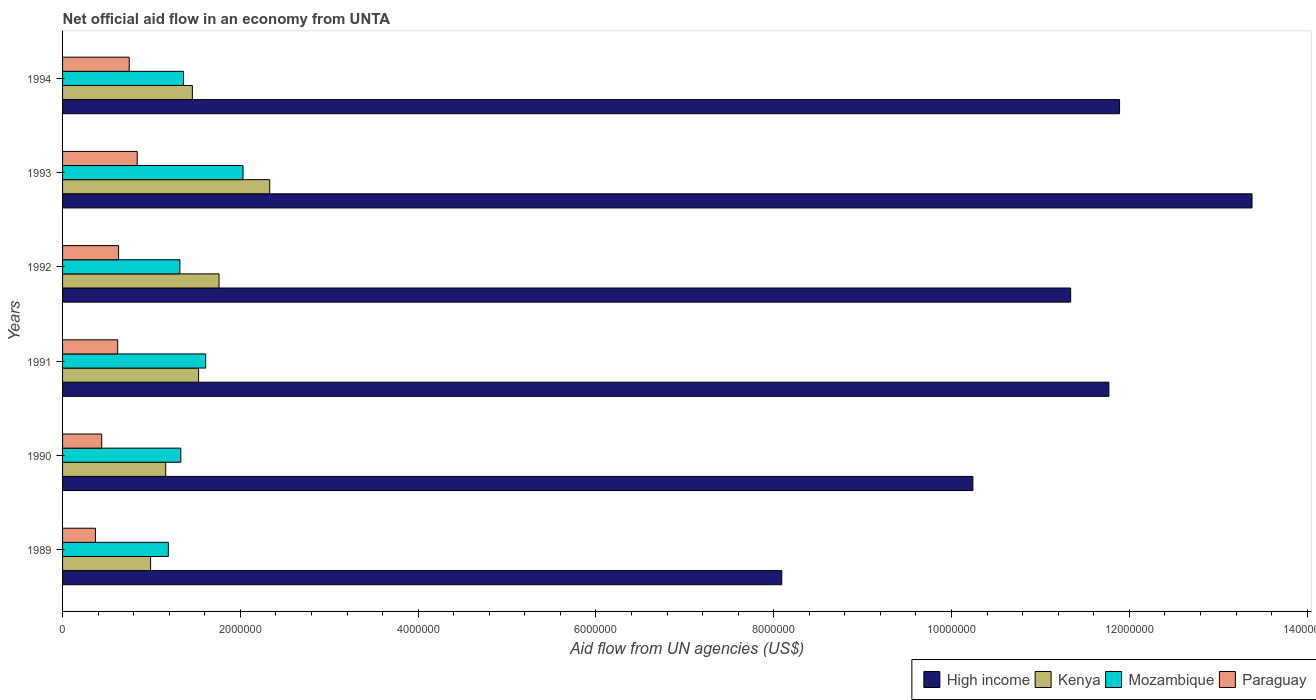How many different coloured bars are there?
Your answer should be compact. 4. Are the number of bars per tick equal to the number of legend labels?
Provide a short and direct response. Yes. In how many cases, is the number of bars for a given year not equal to the number of legend labels?
Ensure brevity in your answer.  0. What is the net official aid flow in Paraguay in 1994?
Give a very brief answer. 7.50e+05. Across all years, what is the maximum net official aid flow in Paraguay?
Give a very brief answer. 8.40e+05. Across all years, what is the minimum net official aid flow in Paraguay?
Offer a terse response. 3.70e+05. What is the total net official aid flow in High income in the graph?
Ensure brevity in your answer.  6.67e+07. What is the difference between the net official aid flow in High income in 1991 and that in 1993?
Provide a short and direct response. -1.61e+06. What is the difference between the net official aid flow in Kenya in 1994 and the net official aid flow in High income in 1993?
Make the answer very short. -1.19e+07. What is the average net official aid flow in Mozambique per year?
Offer a terse response. 1.47e+06. In the year 1992, what is the difference between the net official aid flow in High income and net official aid flow in Paraguay?
Your answer should be compact. 1.07e+07. What is the ratio of the net official aid flow in High income in 1991 to that in 1992?
Provide a succinct answer. 1.04. Is the net official aid flow in Mozambique in 1989 less than that in 1993?
Offer a very short reply. Yes. Is the difference between the net official aid flow in High income in 1989 and 1993 greater than the difference between the net official aid flow in Paraguay in 1989 and 1993?
Make the answer very short. No. What is the difference between the highest and the second highest net official aid flow in High income?
Make the answer very short. 1.49e+06. What is the difference between the highest and the lowest net official aid flow in High income?
Give a very brief answer. 5.29e+06. In how many years, is the net official aid flow in Mozambique greater than the average net official aid flow in Mozambique taken over all years?
Make the answer very short. 2. What does the 3rd bar from the top in 1993 represents?
Make the answer very short. Kenya. What does the 4th bar from the bottom in 1994 represents?
Give a very brief answer. Paraguay. Is it the case that in every year, the sum of the net official aid flow in Kenya and net official aid flow in Paraguay is greater than the net official aid flow in High income?
Provide a succinct answer. No. Are all the bars in the graph horizontal?
Keep it short and to the point. Yes. How many years are there in the graph?
Make the answer very short. 6. What is the difference between two consecutive major ticks on the X-axis?
Give a very brief answer. 2.00e+06. Does the graph contain any zero values?
Offer a terse response. No. Does the graph contain grids?
Make the answer very short. No. What is the title of the graph?
Give a very brief answer. Net official aid flow in an economy from UNTA. What is the label or title of the X-axis?
Make the answer very short. Aid flow from UN agencies (US$). What is the label or title of the Y-axis?
Keep it short and to the point. Years. What is the Aid flow from UN agencies (US$) of High income in 1989?
Ensure brevity in your answer.  8.09e+06. What is the Aid flow from UN agencies (US$) of Kenya in 1989?
Offer a terse response. 9.90e+05. What is the Aid flow from UN agencies (US$) in Mozambique in 1989?
Give a very brief answer. 1.19e+06. What is the Aid flow from UN agencies (US$) in High income in 1990?
Provide a short and direct response. 1.02e+07. What is the Aid flow from UN agencies (US$) of Kenya in 1990?
Offer a terse response. 1.16e+06. What is the Aid flow from UN agencies (US$) in Mozambique in 1990?
Give a very brief answer. 1.33e+06. What is the Aid flow from UN agencies (US$) in High income in 1991?
Provide a short and direct response. 1.18e+07. What is the Aid flow from UN agencies (US$) in Kenya in 1991?
Your answer should be compact. 1.53e+06. What is the Aid flow from UN agencies (US$) of Mozambique in 1991?
Your answer should be very brief. 1.61e+06. What is the Aid flow from UN agencies (US$) of Paraguay in 1991?
Your answer should be very brief. 6.20e+05. What is the Aid flow from UN agencies (US$) in High income in 1992?
Provide a short and direct response. 1.13e+07. What is the Aid flow from UN agencies (US$) in Kenya in 1992?
Provide a short and direct response. 1.76e+06. What is the Aid flow from UN agencies (US$) in Mozambique in 1992?
Your response must be concise. 1.32e+06. What is the Aid flow from UN agencies (US$) in Paraguay in 1992?
Provide a short and direct response. 6.30e+05. What is the Aid flow from UN agencies (US$) of High income in 1993?
Make the answer very short. 1.34e+07. What is the Aid flow from UN agencies (US$) in Kenya in 1993?
Offer a very short reply. 2.33e+06. What is the Aid flow from UN agencies (US$) of Mozambique in 1993?
Ensure brevity in your answer.  2.03e+06. What is the Aid flow from UN agencies (US$) in Paraguay in 1993?
Give a very brief answer. 8.40e+05. What is the Aid flow from UN agencies (US$) in High income in 1994?
Ensure brevity in your answer.  1.19e+07. What is the Aid flow from UN agencies (US$) of Kenya in 1994?
Offer a very short reply. 1.46e+06. What is the Aid flow from UN agencies (US$) of Mozambique in 1994?
Offer a very short reply. 1.36e+06. What is the Aid flow from UN agencies (US$) of Paraguay in 1994?
Offer a terse response. 7.50e+05. Across all years, what is the maximum Aid flow from UN agencies (US$) in High income?
Provide a short and direct response. 1.34e+07. Across all years, what is the maximum Aid flow from UN agencies (US$) in Kenya?
Offer a very short reply. 2.33e+06. Across all years, what is the maximum Aid flow from UN agencies (US$) in Mozambique?
Your response must be concise. 2.03e+06. Across all years, what is the maximum Aid flow from UN agencies (US$) in Paraguay?
Provide a succinct answer. 8.40e+05. Across all years, what is the minimum Aid flow from UN agencies (US$) in High income?
Provide a succinct answer. 8.09e+06. Across all years, what is the minimum Aid flow from UN agencies (US$) in Kenya?
Your answer should be very brief. 9.90e+05. Across all years, what is the minimum Aid flow from UN agencies (US$) of Mozambique?
Your answer should be very brief. 1.19e+06. Across all years, what is the minimum Aid flow from UN agencies (US$) in Paraguay?
Provide a short and direct response. 3.70e+05. What is the total Aid flow from UN agencies (US$) of High income in the graph?
Offer a terse response. 6.67e+07. What is the total Aid flow from UN agencies (US$) of Kenya in the graph?
Make the answer very short. 9.23e+06. What is the total Aid flow from UN agencies (US$) of Mozambique in the graph?
Offer a very short reply. 8.84e+06. What is the total Aid flow from UN agencies (US$) of Paraguay in the graph?
Offer a terse response. 3.65e+06. What is the difference between the Aid flow from UN agencies (US$) in High income in 1989 and that in 1990?
Provide a succinct answer. -2.15e+06. What is the difference between the Aid flow from UN agencies (US$) in High income in 1989 and that in 1991?
Make the answer very short. -3.68e+06. What is the difference between the Aid flow from UN agencies (US$) of Kenya in 1989 and that in 1991?
Your response must be concise. -5.40e+05. What is the difference between the Aid flow from UN agencies (US$) in Mozambique in 1989 and that in 1991?
Your answer should be very brief. -4.20e+05. What is the difference between the Aid flow from UN agencies (US$) of High income in 1989 and that in 1992?
Your response must be concise. -3.25e+06. What is the difference between the Aid flow from UN agencies (US$) of Kenya in 1989 and that in 1992?
Keep it short and to the point. -7.70e+05. What is the difference between the Aid flow from UN agencies (US$) of Mozambique in 1989 and that in 1992?
Make the answer very short. -1.30e+05. What is the difference between the Aid flow from UN agencies (US$) of Paraguay in 1989 and that in 1992?
Provide a short and direct response. -2.60e+05. What is the difference between the Aid flow from UN agencies (US$) of High income in 1989 and that in 1993?
Offer a terse response. -5.29e+06. What is the difference between the Aid flow from UN agencies (US$) in Kenya in 1989 and that in 1993?
Make the answer very short. -1.34e+06. What is the difference between the Aid flow from UN agencies (US$) in Mozambique in 1989 and that in 1993?
Offer a very short reply. -8.40e+05. What is the difference between the Aid flow from UN agencies (US$) in Paraguay in 1989 and that in 1993?
Offer a terse response. -4.70e+05. What is the difference between the Aid flow from UN agencies (US$) in High income in 1989 and that in 1994?
Offer a terse response. -3.80e+06. What is the difference between the Aid flow from UN agencies (US$) of Kenya in 1989 and that in 1994?
Offer a very short reply. -4.70e+05. What is the difference between the Aid flow from UN agencies (US$) in Paraguay in 1989 and that in 1994?
Ensure brevity in your answer.  -3.80e+05. What is the difference between the Aid flow from UN agencies (US$) in High income in 1990 and that in 1991?
Keep it short and to the point. -1.53e+06. What is the difference between the Aid flow from UN agencies (US$) in Kenya in 1990 and that in 1991?
Ensure brevity in your answer.  -3.70e+05. What is the difference between the Aid flow from UN agencies (US$) in Mozambique in 1990 and that in 1991?
Provide a succinct answer. -2.80e+05. What is the difference between the Aid flow from UN agencies (US$) in Paraguay in 1990 and that in 1991?
Offer a very short reply. -1.80e+05. What is the difference between the Aid flow from UN agencies (US$) in High income in 1990 and that in 1992?
Provide a succinct answer. -1.10e+06. What is the difference between the Aid flow from UN agencies (US$) in Kenya in 1990 and that in 1992?
Offer a very short reply. -6.00e+05. What is the difference between the Aid flow from UN agencies (US$) in Mozambique in 1990 and that in 1992?
Your response must be concise. 10000. What is the difference between the Aid flow from UN agencies (US$) in Paraguay in 1990 and that in 1992?
Keep it short and to the point. -1.90e+05. What is the difference between the Aid flow from UN agencies (US$) of High income in 1990 and that in 1993?
Your answer should be very brief. -3.14e+06. What is the difference between the Aid flow from UN agencies (US$) in Kenya in 1990 and that in 1993?
Your answer should be compact. -1.17e+06. What is the difference between the Aid flow from UN agencies (US$) in Mozambique in 1990 and that in 1993?
Provide a succinct answer. -7.00e+05. What is the difference between the Aid flow from UN agencies (US$) of Paraguay in 1990 and that in 1993?
Provide a short and direct response. -4.00e+05. What is the difference between the Aid flow from UN agencies (US$) of High income in 1990 and that in 1994?
Provide a succinct answer. -1.65e+06. What is the difference between the Aid flow from UN agencies (US$) in Mozambique in 1990 and that in 1994?
Keep it short and to the point. -3.00e+04. What is the difference between the Aid flow from UN agencies (US$) in Paraguay in 1990 and that in 1994?
Make the answer very short. -3.10e+05. What is the difference between the Aid flow from UN agencies (US$) of High income in 1991 and that in 1992?
Provide a short and direct response. 4.30e+05. What is the difference between the Aid flow from UN agencies (US$) of Mozambique in 1991 and that in 1992?
Offer a very short reply. 2.90e+05. What is the difference between the Aid flow from UN agencies (US$) in High income in 1991 and that in 1993?
Ensure brevity in your answer.  -1.61e+06. What is the difference between the Aid flow from UN agencies (US$) in Kenya in 1991 and that in 1993?
Ensure brevity in your answer.  -8.00e+05. What is the difference between the Aid flow from UN agencies (US$) of Mozambique in 1991 and that in 1993?
Your answer should be very brief. -4.20e+05. What is the difference between the Aid flow from UN agencies (US$) of Paraguay in 1991 and that in 1994?
Keep it short and to the point. -1.30e+05. What is the difference between the Aid flow from UN agencies (US$) of High income in 1992 and that in 1993?
Ensure brevity in your answer.  -2.04e+06. What is the difference between the Aid flow from UN agencies (US$) in Kenya in 1992 and that in 1993?
Your answer should be very brief. -5.70e+05. What is the difference between the Aid flow from UN agencies (US$) of Mozambique in 1992 and that in 1993?
Offer a terse response. -7.10e+05. What is the difference between the Aid flow from UN agencies (US$) of High income in 1992 and that in 1994?
Give a very brief answer. -5.50e+05. What is the difference between the Aid flow from UN agencies (US$) of Paraguay in 1992 and that in 1994?
Give a very brief answer. -1.20e+05. What is the difference between the Aid flow from UN agencies (US$) in High income in 1993 and that in 1994?
Your answer should be compact. 1.49e+06. What is the difference between the Aid flow from UN agencies (US$) in Kenya in 1993 and that in 1994?
Ensure brevity in your answer.  8.70e+05. What is the difference between the Aid flow from UN agencies (US$) in Mozambique in 1993 and that in 1994?
Ensure brevity in your answer.  6.70e+05. What is the difference between the Aid flow from UN agencies (US$) of Paraguay in 1993 and that in 1994?
Your answer should be compact. 9.00e+04. What is the difference between the Aid flow from UN agencies (US$) of High income in 1989 and the Aid flow from UN agencies (US$) of Kenya in 1990?
Your answer should be compact. 6.93e+06. What is the difference between the Aid flow from UN agencies (US$) in High income in 1989 and the Aid flow from UN agencies (US$) in Mozambique in 1990?
Offer a terse response. 6.76e+06. What is the difference between the Aid flow from UN agencies (US$) in High income in 1989 and the Aid flow from UN agencies (US$) in Paraguay in 1990?
Make the answer very short. 7.65e+06. What is the difference between the Aid flow from UN agencies (US$) of Kenya in 1989 and the Aid flow from UN agencies (US$) of Mozambique in 1990?
Your response must be concise. -3.40e+05. What is the difference between the Aid flow from UN agencies (US$) in Kenya in 1989 and the Aid flow from UN agencies (US$) in Paraguay in 1990?
Keep it short and to the point. 5.50e+05. What is the difference between the Aid flow from UN agencies (US$) of Mozambique in 1989 and the Aid flow from UN agencies (US$) of Paraguay in 1990?
Give a very brief answer. 7.50e+05. What is the difference between the Aid flow from UN agencies (US$) of High income in 1989 and the Aid flow from UN agencies (US$) of Kenya in 1991?
Keep it short and to the point. 6.56e+06. What is the difference between the Aid flow from UN agencies (US$) of High income in 1989 and the Aid flow from UN agencies (US$) of Mozambique in 1991?
Keep it short and to the point. 6.48e+06. What is the difference between the Aid flow from UN agencies (US$) in High income in 1989 and the Aid flow from UN agencies (US$) in Paraguay in 1991?
Give a very brief answer. 7.47e+06. What is the difference between the Aid flow from UN agencies (US$) in Kenya in 1989 and the Aid flow from UN agencies (US$) in Mozambique in 1991?
Your answer should be very brief. -6.20e+05. What is the difference between the Aid flow from UN agencies (US$) in Kenya in 1989 and the Aid flow from UN agencies (US$) in Paraguay in 1991?
Ensure brevity in your answer.  3.70e+05. What is the difference between the Aid flow from UN agencies (US$) of Mozambique in 1989 and the Aid flow from UN agencies (US$) of Paraguay in 1991?
Offer a very short reply. 5.70e+05. What is the difference between the Aid flow from UN agencies (US$) in High income in 1989 and the Aid flow from UN agencies (US$) in Kenya in 1992?
Make the answer very short. 6.33e+06. What is the difference between the Aid flow from UN agencies (US$) in High income in 1989 and the Aid flow from UN agencies (US$) in Mozambique in 1992?
Provide a succinct answer. 6.77e+06. What is the difference between the Aid flow from UN agencies (US$) of High income in 1989 and the Aid flow from UN agencies (US$) of Paraguay in 1992?
Your answer should be compact. 7.46e+06. What is the difference between the Aid flow from UN agencies (US$) of Kenya in 1989 and the Aid flow from UN agencies (US$) of Mozambique in 1992?
Offer a terse response. -3.30e+05. What is the difference between the Aid flow from UN agencies (US$) of Mozambique in 1989 and the Aid flow from UN agencies (US$) of Paraguay in 1992?
Your answer should be compact. 5.60e+05. What is the difference between the Aid flow from UN agencies (US$) in High income in 1989 and the Aid flow from UN agencies (US$) in Kenya in 1993?
Your answer should be very brief. 5.76e+06. What is the difference between the Aid flow from UN agencies (US$) of High income in 1989 and the Aid flow from UN agencies (US$) of Mozambique in 1993?
Your answer should be very brief. 6.06e+06. What is the difference between the Aid flow from UN agencies (US$) in High income in 1989 and the Aid flow from UN agencies (US$) in Paraguay in 1993?
Provide a short and direct response. 7.25e+06. What is the difference between the Aid flow from UN agencies (US$) of Kenya in 1989 and the Aid flow from UN agencies (US$) of Mozambique in 1993?
Provide a succinct answer. -1.04e+06. What is the difference between the Aid flow from UN agencies (US$) of High income in 1989 and the Aid flow from UN agencies (US$) of Kenya in 1994?
Your answer should be very brief. 6.63e+06. What is the difference between the Aid flow from UN agencies (US$) of High income in 1989 and the Aid flow from UN agencies (US$) of Mozambique in 1994?
Offer a terse response. 6.73e+06. What is the difference between the Aid flow from UN agencies (US$) in High income in 1989 and the Aid flow from UN agencies (US$) in Paraguay in 1994?
Ensure brevity in your answer.  7.34e+06. What is the difference between the Aid flow from UN agencies (US$) of Kenya in 1989 and the Aid flow from UN agencies (US$) of Mozambique in 1994?
Offer a terse response. -3.70e+05. What is the difference between the Aid flow from UN agencies (US$) in Mozambique in 1989 and the Aid flow from UN agencies (US$) in Paraguay in 1994?
Make the answer very short. 4.40e+05. What is the difference between the Aid flow from UN agencies (US$) of High income in 1990 and the Aid flow from UN agencies (US$) of Kenya in 1991?
Your answer should be very brief. 8.71e+06. What is the difference between the Aid flow from UN agencies (US$) in High income in 1990 and the Aid flow from UN agencies (US$) in Mozambique in 1991?
Ensure brevity in your answer.  8.63e+06. What is the difference between the Aid flow from UN agencies (US$) of High income in 1990 and the Aid flow from UN agencies (US$) of Paraguay in 1991?
Ensure brevity in your answer.  9.62e+06. What is the difference between the Aid flow from UN agencies (US$) in Kenya in 1990 and the Aid flow from UN agencies (US$) in Mozambique in 1991?
Your answer should be very brief. -4.50e+05. What is the difference between the Aid flow from UN agencies (US$) of Kenya in 1990 and the Aid flow from UN agencies (US$) of Paraguay in 1991?
Keep it short and to the point. 5.40e+05. What is the difference between the Aid flow from UN agencies (US$) of Mozambique in 1990 and the Aid flow from UN agencies (US$) of Paraguay in 1991?
Offer a terse response. 7.10e+05. What is the difference between the Aid flow from UN agencies (US$) in High income in 1990 and the Aid flow from UN agencies (US$) in Kenya in 1992?
Provide a short and direct response. 8.48e+06. What is the difference between the Aid flow from UN agencies (US$) of High income in 1990 and the Aid flow from UN agencies (US$) of Mozambique in 1992?
Your response must be concise. 8.92e+06. What is the difference between the Aid flow from UN agencies (US$) in High income in 1990 and the Aid flow from UN agencies (US$) in Paraguay in 1992?
Offer a very short reply. 9.61e+06. What is the difference between the Aid flow from UN agencies (US$) of Kenya in 1990 and the Aid flow from UN agencies (US$) of Mozambique in 1992?
Offer a very short reply. -1.60e+05. What is the difference between the Aid flow from UN agencies (US$) in Kenya in 1990 and the Aid flow from UN agencies (US$) in Paraguay in 1992?
Ensure brevity in your answer.  5.30e+05. What is the difference between the Aid flow from UN agencies (US$) in High income in 1990 and the Aid flow from UN agencies (US$) in Kenya in 1993?
Provide a short and direct response. 7.91e+06. What is the difference between the Aid flow from UN agencies (US$) of High income in 1990 and the Aid flow from UN agencies (US$) of Mozambique in 1993?
Provide a short and direct response. 8.21e+06. What is the difference between the Aid flow from UN agencies (US$) of High income in 1990 and the Aid flow from UN agencies (US$) of Paraguay in 1993?
Provide a short and direct response. 9.40e+06. What is the difference between the Aid flow from UN agencies (US$) in Kenya in 1990 and the Aid flow from UN agencies (US$) in Mozambique in 1993?
Your answer should be very brief. -8.70e+05. What is the difference between the Aid flow from UN agencies (US$) of Mozambique in 1990 and the Aid flow from UN agencies (US$) of Paraguay in 1993?
Your answer should be very brief. 4.90e+05. What is the difference between the Aid flow from UN agencies (US$) of High income in 1990 and the Aid flow from UN agencies (US$) of Kenya in 1994?
Make the answer very short. 8.78e+06. What is the difference between the Aid flow from UN agencies (US$) of High income in 1990 and the Aid flow from UN agencies (US$) of Mozambique in 1994?
Provide a succinct answer. 8.88e+06. What is the difference between the Aid flow from UN agencies (US$) in High income in 1990 and the Aid flow from UN agencies (US$) in Paraguay in 1994?
Offer a very short reply. 9.49e+06. What is the difference between the Aid flow from UN agencies (US$) of Kenya in 1990 and the Aid flow from UN agencies (US$) of Paraguay in 1994?
Your response must be concise. 4.10e+05. What is the difference between the Aid flow from UN agencies (US$) in Mozambique in 1990 and the Aid flow from UN agencies (US$) in Paraguay in 1994?
Your answer should be very brief. 5.80e+05. What is the difference between the Aid flow from UN agencies (US$) of High income in 1991 and the Aid flow from UN agencies (US$) of Kenya in 1992?
Keep it short and to the point. 1.00e+07. What is the difference between the Aid flow from UN agencies (US$) of High income in 1991 and the Aid flow from UN agencies (US$) of Mozambique in 1992?
Ensure brevity in your answer.  1.04e+07. What is the difference between the Aid flow from UN agencies (US$) in High income in 1991 and the Aid flow from UN agencies (US$) in Paraguay in 1992?
Give a very brief answer. 1.11e+07. What is the difference between the Aid flow from UN agencies (US$) of Kenya in 1991 and the Aid flow from UN agencies (US$) of Mozambique in 1992?
Your response must be concise. 2.10e+05. What is the difference between the Aid flow from UN agencies (US$) of Mozambique in 1991 and the Aid flow from UN agencies (US$) of Paraguay in 1992?
Your answer should be compact. 9.80e+05. What is the difference between the Aid flow from UN agencies (US$) of High income in 1991 and the Aid flow from UN agencies (US$) of Kenya in 1993?
Offer a very short reply. 9.44e+06. What is the difference between the Aid flow from UN agencies (US$) of High income in 1991 and the Aid flow from UN agencies (US$) of Mozambique in 1993?
Keep it short and to the point. 9.74e+06. What is the difference between the Aid flow from UN agencies (US$) of High income in 1991 and the Aid flow from UN agencies (US$) of Paraguay in 1993?
Offer a very short reply. 1.09e+07. What is the difference between the Aid flow from UN agencies (US$) in Kenya in 1991 and the Aid flow from UN agencies (US$) in Mozambique in 1993?
Your answer should be very brief. -5.00e+05. What is the difference between the Aid flow from UN agencies (US$) in Kenya in 1991 and the Aid flow from UN agencies (US$) in Paraguay in 1993?
Your answer should be very brief. 6.90e+05. What is the difference between the Aid flow from UN agencies (US$) of Mozambique in 1991 and the Aid flow from UN agencies (US$) of Paraguay in 1993?
Make the answer very short. 7.70e+05. What is the difference between the Aid flow from UN agencies (US$) in High income in 1991 and the Aid flow from UN agencies (US$) in Kenya in 1994?
Offer a very short reply. 1.03e+07. What is the difference between the Aid flow from UN agencies (US$) in High income in 1991 and the Aid flow from UN agencies (US$) in Mozambique in 1994?
Your answer should be compact. 1.04e+07. What is the difference between the Aid flow from UN agencies (US$) in High income in 1991 and the Aid flow from UN agencies (US$) in Paraguay in 1994?
Make the answer very short. 1.10e+07. What is the difference between the Aid flow from UN agencies (US$) in Kenya in 1991 and the Aid flow from UN agencies (US$) in Paraguay in 1994?
Provide a short and direct response. 7.80e+05. What is the difference between the Aid flow from UN agencies (US$) of Mozambique in 1991 and the Aid flow from UN agencies (US$) of Paraguay in 1994?
Make the answer very short. 8.60e+05. What is the difference between the Aid flow from UN agencies (US$) in High income in 1992 and the Aid flow from UN agencies (US$) in Kenya in 1993?
Your answer should be very brief. 9.01e+06. What is the difference between the Aid flow from UN agencies (US$) of High income in 1992 and the Aid flow from UN agencies (US$) of Mozambique in 1993?
Your answer should be very brief. 9.31e+06. What is the difference between the Aid flow from UN agencies (US$) of High income in 1992 and the Aid flow from UN agencies (US$) of Paraguay in 1993?
Make the answer very short. 1.05e+07. What is the difference between the Aid flow from UN agencies (US$) of Kenya in 1992 and the Aid flow from UN agencies (US$) of Paraguay in 1993?
Your response must be concise. 9.20e+05. What is the difference between the Aid flow from UN agencies (US$) of Mozambique in 1992 and the Aid flow from UN agencies (US$) of Paraguay in 1993?
Give a very brief answer. 4.80e+05. What is the difference between the Aid flow from UN agencies (US$) of High income in 1992 and the Aid flow from UN agencies (US$) of Kenya in 1994?
Offer a terse response. 9.88e+06. What is the difference between the Aid flow from UN agencies (US$) of High income in 1992 and the Aid flow from UN agencies (US$) of Mozambique in 1994?
Offer a terse response. 9.98e+06. What is the difference between the Aid flow from UN agencies (US$) in High income in 1992 and the Aid flow from UN agencies (US$) in Paraguay in 1994?
Give a very brief answer. 1.06e+07. What is the difference between the Aid flow from UN agencies (US$) of Kenya in 1992 and the Aid flow from UN agencies (US$) of Mozambique in 1994?
Ensure brevity in your answer.  4.00e+05. What is the difference between the Aid flow from UN agencies (US$) in Kenya in 1992 and the Aid flow from UN agencies (US$) in Paraguay in 1994?
Provide a short and direct response. 1.01e+06. What is the difference between the Aid flow from UN agencies (US$) of Mozambique in 1992 and the Aid flow from UN agencies (US$) of Paraguay in 1994?
Offer a very short reply. 5.70e+05. What is the difference between the Aid flow from UN agencies (US$) in High income in 1993 and the Aid flow from UN agencies (US$) in Kenya in 1994?
Ensure brevity in your answer.  1.19e+07. What is the difference between the Aid flow from UN agencies (US$) in High income in 1993 and the Aid flow from UN agencies (US$) in Mozambique in 1994?
Give a very brief answer. 1.20e+07. What is the difference between the Aid flow from UN agencies (US$) of High income in 1993 and the Aid flow from UN agencies (US$) of Paraguay in 1994?
Your answer should be very brief. 1.26e+07. What is the difference between the Aid flow from UN agencies (US$) in Kenya in 1993 and the Aid flow from UN agencies (US$) in Mozambique in 1994?
Provide a succinct answer. 9.70e+05. What is the difference between the Aid flow from UN agencies (US$) in Kenya in 1993 and the Aid flow from UN agencies (US$) in Paraguay in 1994?
Offer a terse response. 1.58e+06. What is the difference between the Aid flow from UN agencies (US$) of Mozambique in 1993 and the Aid flow from UN agencies (US$) of Paraguay in 1994?
Make the answer very short. 1.28e+06. What is the average Aid flow from UN agencies (US$) in High income per year?
Offer a very short reply. 1.11e+07. What is the average Aid flow from UN agencies (US$) in Kenya per year?
Ensure brevity in your answer.  1.54e+06. What is the average Aid flow from UN agencies (US$) of Mozambique per year?
Keep it short and to the point. 1.47e+06. What is the average Aid flow from UN agencies (US$) of Paraguay per year?
Ensure brevity in your answer.  6.08e+05. In the year 1989, what is the difference between the Aid flow from UN agencies (US$) of High income and Aid flow from UN agencies (US$) of Kenya?
Make the answer very short. 7.10e+06. In the year 1989, what is the difference between the Aid flow from UN agencies (US$) in High income and Aid flow from UN agencies (US$) in Mozambique?
Your answer should be very brief. 6.90e+06. In the year 1989, what is the difference between the Aid flow from UN agencies (US$) of High income and Aid flow from UN agencies (US$) of Paraguay?
Your answer should be very brief. 7.72e+06. In the year 1989, what is the difference between the Aid flow from UN agencies (US$) in Kenya and Aid flow from UN agencies (US$) in Mozambique?
Offer a terse response. -2.00e+05. In the year 1989, what is the difference between the Aid flow from UN agencies (US$) in Kenya and Aid flow from UN agencies (US$) in Paraguay?
Make the answer very short. 6.20e+05. In the year 1989, what is the difference between the Aid flow from UN agencies (US$) of Mozambique and Aid flow from UN agencies (US$) of Paraguay?
Provide a succinct answer. 8.20e+05. In the year 1990, what is the difference between the Aid flow from UN agencies (US$) of High income and Aid flow from UN agencies (US$) of Kenya?
Give a very brief answer. 9.08e+06. In the year 1990, what is the difference between the Aid flow from UN agencies (US$) in High income and Aid flow from UN agencies (US$) in Mozambique?
Make the answer very short. 8.91e+06. In the year 1990, what is the difference between the Aid flow from UN agencies (US$) of High income and Aid flow from UN agencies (US$) of Paraguay?
Keep it short and to the point. 9.80e+06. In the year 1990, what is the difference between the Aid flow from UN agencies (US$) in Kenya and Aid flow from UN agencies (US$) in Mozambique?
Give a very brief answer. -1.70e+05. In the year 1990, what is the difference between the Aid flow from UN agencies (US$) of Kenya and Aid flow from UN agencies (US$) of Paraguay?
Ensure brevity in your answer.  7.20e+05. In the year 1990, what is the difference between the Aid flow from UN agencies (US$) in Mozambique and Aid flow from UN agencies (US$) in Paraguay?
Give a very brief answer. 8.90e+05. In the year 1991, what is the difference between the Aid flow from UN agencies (US$) of High income and Aid flow from UN agencies (US$) of Kenya?
Provide a succinct answer. 1.02e+07. In the year 1991, what is the difference between the Aid flow from UN agencies (US$) in High income and Aid flow from UN agencies (US$) in Mozambique?
Make the answer very short. 1.02e+07. In the year 1991, what is the difference between the Aid flow from UN agencies (US$) in High income and Aid flow from UN agencies (US$) in Paraguay?
Your answer should be compact. 1.12e+07. In the year 1991, what is the difference between the Aid flow from UN agencies (US$) of Kenya and Aid flow from UN agencies (US$) of Mozambique?
Give a very brief answer. -8.00e+04. In the year 1991, what is the difference between the Aid flow from UN agencies (US$) of Kenya and Aid flow from UN agencies (US$) of Paraguay?
Make the answer very short. 9.10e+05. In the year 1991, what is the difference between the Aid flow from UN agencies (US$) in Mozambique and Aid flow from UN agencies (US$) in Paraguay?
Ensure brevity in your answer.  9.90e+05. In the year 1992, what is the difference between the Aid flow from UN agencies (US$) in High income and Aid flow from UN agencies (US$) in Kenya?
Offer a terse response. 9.58e+06. In the year 1992, what is the difference between the Aid flow from UN agencies (US$) of High income and Aid flow from UN agencies (US$) of Mozambique?
Make the answer very short. 1.00e+07. In the year 1992, what is the difference between the Aid flow from UN agencies (US$) of High income and Aid flow from UN agencies (US$) of Paraguay?
Make the answer very short. 1.07e+07. In the year 1992, what is the difference between the Aid flow from UN agencies (US$) of Kenya and Aid flow from UN agencies (US$) of Mozambique?
Keep it short and to the point. 4.40e+05. In the year 1992, what is the difference between the Aid flow from UN agencies (US$) in Kenya and Aid flow from UN agencies (US$) in Paraguay?
Provide a succinct answer. 1.13e+06. In the year 1992, what is the difference between the Aid flow from UN agencies (US$) of Mozambique and Aid flow from UN agencies (US$) of Paraguay?
Provide a short and direct response. 6.90e+05. In the year 1993, what is the difference between the Aid flow from UN agencies (US$) in High income and Aid flow from UN agencies (US$) in Kenya?
Offer a very short reply. 1.10e+07. In the year 1993, what is the difference between the Aid flow from UN agencies (US$) in High income and Aid flow from UN agencies (US$) in Mozambique?
Offer a very short reply. 1.14e+07. In the year 1993, what is the difference between the Aid flow from UN agencies (US$) of High income and Aid flow from UN agencies (US$) of Paraguay?
Provide a short and direct response. 1.25e+07. In the year 1993, what is the difference between the Aid flow from UN agencies (US$) in Kenya and Aid flow from UN agencies (US$) in Paraguay?
Provide a short and direct response. 1.49e+06. In the year 1993, what is the difference between the Aid flow from UN agencies (US$) of Mozambique and Aid flow from UN agencies (US$) of Paraguay?
Offer a very short reply. 1.19e+06. In the year 1994, what is the difference between the Aid flow from UN agencies (US$) in High income and Aid flow from UN agencies (US$) in Kenya?
Make the answer very short. 1.04e+07. In the year 1994, what is the difference between the Aid flow from UN agencies (US$) in High income and Aid flow from UN agencies (US$) in Mozambique?
Your response must be concise. 1.05e+07. In the year 1994, what is the difference between the Aid flow from UN agencies (US$) of High income and Aid flow from UN agencies (US$) of Paraguay?
Your answer should be very brief. 1.11e+07. In the year 1994, what is the difference between the Aid flow from UN agencies (US$) of Kenya and Aid flow from UN agencies (US$) of Paraguay?
Keep it short and to the point. 7.10e+05. In the year 1994, what is the difference between the Aid flow from UN agencies (US$) in Mozambique and Aid flow from UN agencies (US$) in Paraguay?
Give a very brief answer. 6.10e+05. What is the ratio of the Aid flow from UN agencies (US$) of High income in 1989 to that in 1990?
Make the answer very short. 0.79. What is the ratio of the Aid flow from UN agencies (US$) in Kenya in 1989 to that in 1990?
Ensure brevity in your answer.  0.85. What is the ratio of the Aid flow from UN agencies (US$) of Mozambique in 1989 to that in 1990?
Ensure brevity in your answer.  0.89. What is the ratio of the Aid flow from UN agencies (US$) in Paraguay in 1989 to that in 1990?
Your answer should be compact. 0.84. What is the ratio of the Aid flow from UN agencies (US$) of High income in 1989 to that in 1991?
Make the answer very short. 0.69. What is the ratio of the Aid flow from UN agencies (US$) in Kenya in 1989 to that in 1991?
Your answer should be very brief. 0.65. What is the ratio of the Aid flow from UN agencies (US$) of Mozambique in 1989 to that in 1991?
Provide a succinct answer. 0.74. What is the ratio of the Aid flow from UN agencies (US$) of Paraguay in 1989 to that in 1991?
Offer a very short reply. 0.6. What is the ratio of the Aid flow from UN agencies (US$) of High income in 1989 to that in 1992?
Keep it short and to the point. 0.71. What is the ratio of the Aid flow from UN agencies (US$) of Kenya in 1989 to that in 1992?
Give a very brief answer. 0.56. What is the ratio of the Aid flow from UN agencies (US$) in Mozambique in 1989 to that in 1992?
Make the answer very short. 0.9. What is the ratio of the Aid flow from UN agencies (US$) of Paraguay in 1989 to that in 1992?
Your answer should be very brief. 0.59. What is the ratio of the Aid flow from UN agencies (US$) of High income in 1989 to that in 1993?
Provide a short and direct response. 0.6. What is the ratio of the Aid flow from UN agencies (US$) of Kenya in 1989 to that in 1993?
Your response must be concise. 0.42. What is the ratio of the Aid flow from UN agencies (US$) in Mozambique in 1989 to that in 1993?
Your answer should be very brief. 0.59. What is the ratio of the Aid flow from UN agencies (US$) of Paraguay in 1989 to that in 1993?
Your answer should be compact. 0.44. What is the ratio of the Aid flow from UN agencies (US$) of High income in 1989 to that in 1994?
Your answer should be compact. 0.68. What is the ratio of the Aid flow from UN agencies (US$) in Kenya in 1989 to that in 1994?
Your answer should be compact. 0.68. What is the ratio of the Aid flow from UN agencies (US$) in Paraguay in 1989 to that in 1994?
Your response must be concise. 0.49. What is the ratio of the Aid flow from UN agencies (US$) of High income in 1990 to that in 1991?
Give a very brief answer. 0.87. What is the ratio of the Aid flow from UN agencies (US$) in Kenya in 1990 to that in 1991?
Provide a succinct answer. 0.76. What is the ratio of the Aid flow from UN agencies (US$) of Mozambique in 1990 to that in 1991?
Offer a very short reply. 0.83. What is the ratio of the Aid flow from UN agencies (US$) in Paraguay in 1990 to that in 1991?
Your response must be concise. 0.71. What is the ratio of the Aid flow from UN agencies (US$) in High income in 1990 to that in 1992?
Provide a succinct answer. 0.9. What is the ratio of the Aid flow from UN agencies (US$) in Kenya in 1990 to that in 1992?
Ensure brevity in your answer.  0.66. What is the ratio of the Aid flow from UN agencies (US$) of Mozambique in 1990 to that in 1992?
Your answer should be compact. 1.01. What is the ratio of the Aid flow from UN agencies (US$) in Paraguay in 1990 to that in 1992?
Ensure brevity in your answer.  0.7. What is the ratio of the Aid flow from UN agencies (US$) of High income in 1990 to that in 1993?
Your response must be concise. 0.77. What is the ratio of the Aid flow from UN agencies (US$) in Kenya in 1990 to that in 1993?
Your response must be concise. 0.5. What is the ratio of the Aid flow from UN agencies (US$) of Mozambique in 1990 to that in 1993?
Your answer should be very brief. 0.66. What is the ratio of the Aid flow from UN agencies (US$) in Paraguay in 1990 to that in 1993?
Offer a terse response. 0.52. What is the ratio of the Aid flow from UN agencies (US$) in High income in 1990 to that in 1994?
Your answer should be very brief. 0.86. What is the ratio of the Aid flow from UN agencies (US$) of Kenya in 1990 to that in 1994?
Provide a succinct answer. 0.79. What is the ratio of the Aid flow from UN agencies (US$) of Mozambique in 1990 to that in 1994?
Your answer should be compact. 0.98. What is the ratio of the Aid flow from UN agencies (US$) in Paraguay in 1990 to that in 1994?
Offer a terse response. 0.59. What is the ratio of the Aid flow from UN agencies (US$) in High income in 1991 to that in 1992?
Ensure brevity in your answer.  1.04. What is the ratio of the Aid flow from UN agencies (US$) of Kenya in 1991 to that in 1992?
Make the answer very short. 0.87. What is the ratio of the Aid flow from UN agencies (US$) in Mozambique in 1991 to that in 1992?
Provide a short and direct response. 1.22. What is the ratio of the Aid flow from UN agencies (US$) in Paraguay in 1991 to that in 1992?
Your answer should be compact. 0.98. What is the ratio of the Aid flow from UN agencies (US$) of High income in 1991 to that in 1993?
Give a very brief answer. 0.88. What is the ratio of the Aid flow from UN agencies (US$) of Kenya in 1991 to that in 1993?
Provide a short and direct response. 0.66. What is the ratio of the Aid flow from UN agencies (US$) of Mozambique in 1991 to that in 1993?
Your response must be concise. 0.79. What is the ratio of the Aid flow from UN agencies (US$) of Paraguay in 1991 to that in 1993?
Provide a succinct answer. 0.74. What is the ratio of the Aid flow from UN agencies (US$) of High income in 1991 to that in 1994?
Keep it short and to the point. 0.99. What is the ratio of the Aid flow from UN agencies (US$) of Kenya in 1991 to that in 1994?
Your answer should be very brief. 1.05. What is the ratio of the Aid flow from UN agencies (US$) of Mozambique in 1991 to that in 1994?
Provide a short and direct response. 1.18. What is the ratio of the Aid flow from UN agencies (US$) of Paraguay in 1991 to that in 1994?
Make the answer very short. 0.83. What is the ratio of the Aid flow from UN agencies (US$) of High income in 1992 to that in 1993?
Give a very brief answer. 0.85. What is the ratio of the Aid flow from UN agencies (US$) in Kenya in 1992 to that in 1993?
Provide a short and direct response. 0.76. What is the ratio of the Aid flow from UN agencies (US$) in Mozambique in 1992 to that in 1993?
Offer a terse response. 0.65. What is the ratio of the Aid flow from UN agencies (US$) in Paraguay in 1992 to that in 1993?
Your response must be concise. 0.75. What is the ratio of the Aid flow from UN agencies (US$) in High income in 1992 to that in 1994?
Offer a terse response. 0.95. What is the ratio of the Aid flow from UN agencies (US$) of Kenya in 1992 to that in 1994?
Ensure brevity in your answer.  1.21. What is the ratio of the Aid flow from UN agencies (US$) in Mozambique in 1992 to that in 1994?
Keep it short and to the point. 0.97. What is the ratio of the Aid flow from UN agencies (US$) in Paraguay in 1992 to that in 1994?
Provide a succinct answer. 0.84. What is the ratio of the Aid flow from UN agencies (US$) of High income in 1993 to that in 1994?
Provide a short and direct response. 1.13. What is the ratio of the Aid flow from UN agencies (US$) of Kenya in 1993 to that in 1994?
Provide a short and direct response. 1.6. What is the ratio of the Aid flow from UN agencies (US$) of Mozambique in 1993 to that in 1994?
Make the answer very short. 1.49. What is the ratio of the Aid flow from UN agencies (US$) of Paraguay in 1993 to that in 1994?
Keep it short and to the point. 1.12. What is the difference between the highest and the second highest Aid flow from UN agencies (US$) in High income?
Offer a very short reply. 1.49e+06. What is the difference between the highest and the second highest Aid flow from UN agencies (US$) in Kenya?
Your answer should be compact. 5.70e+05. What is the difference between the highest and the second highest Aid flow from UN agencies (US$) of Mozambique?
Ensure brevity in your answer.  4.20e+05. What is the difference between the highest and the second highest Aid flow from UN agencies (US$) of Paraguay?
Offer a terse response. 9.00e+04. What is the difference between the highest and the lowest Aid flow from UN agencies (US$) of High income?
Keep it short and to the point. 5.29e+06. What is the difference between the highest and the lowest Aid flow from UN agencies (US$) of Kenya?
Keep it short and to the point. 1.34e+06. What is the difference between the highest and the lowest Aid flow from UN agencies (US$) in Mozambique?
Provide a succinct answer. 8.40e+05. What is the difference between the highest and the lowest Aid flow from UN agencies (US$) in Paraguay?
Keep it short and to the point. 4.70e+05. 